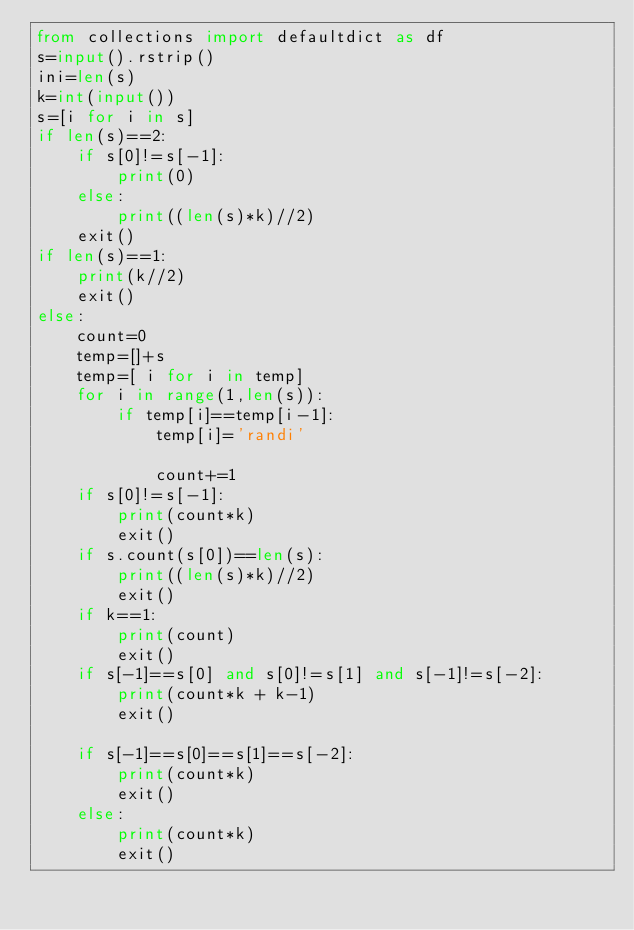<code> <loc_0><loc_0><loc_500><loc_500><_Python_>from collections import defaultdict as df
s=input().rstrip()
ini=len(s)
k=int(input())
s=[i for i in s]
if len(s)==2:
    if s[0]!=s[-1]:
        print(0)
    else:
        print((len(s)*k)//2)
    exit()
if len(s)==1:
    print(k//2)
    exit()
else:
    count=0
    temp=[]+s
    temp=[ i for i in temp]
    for i in range(1,len(s)):
        if temp[i]==temp[i-1]:
            temp[i]='randi'
            
            count+=1
    if s[0]!=s[-1]:
        print(count*k)
        exit()
    if s.count(s[0])==len(s):
        print((len(s)*k)//2)
        exit()
    if k==1:
        print(count)
        exit()
    if s[-1]==s[0] and s[0]!=s[1] and s[-1]!=s[-2]:
        print(count*k + k-1)
        exit()
    
    if s[-1]==s[0]==s[1]==s[-2]:
        print(count*k)
        exit()
    else:
        print(count*k)
        exit()
        
    
    </code> 